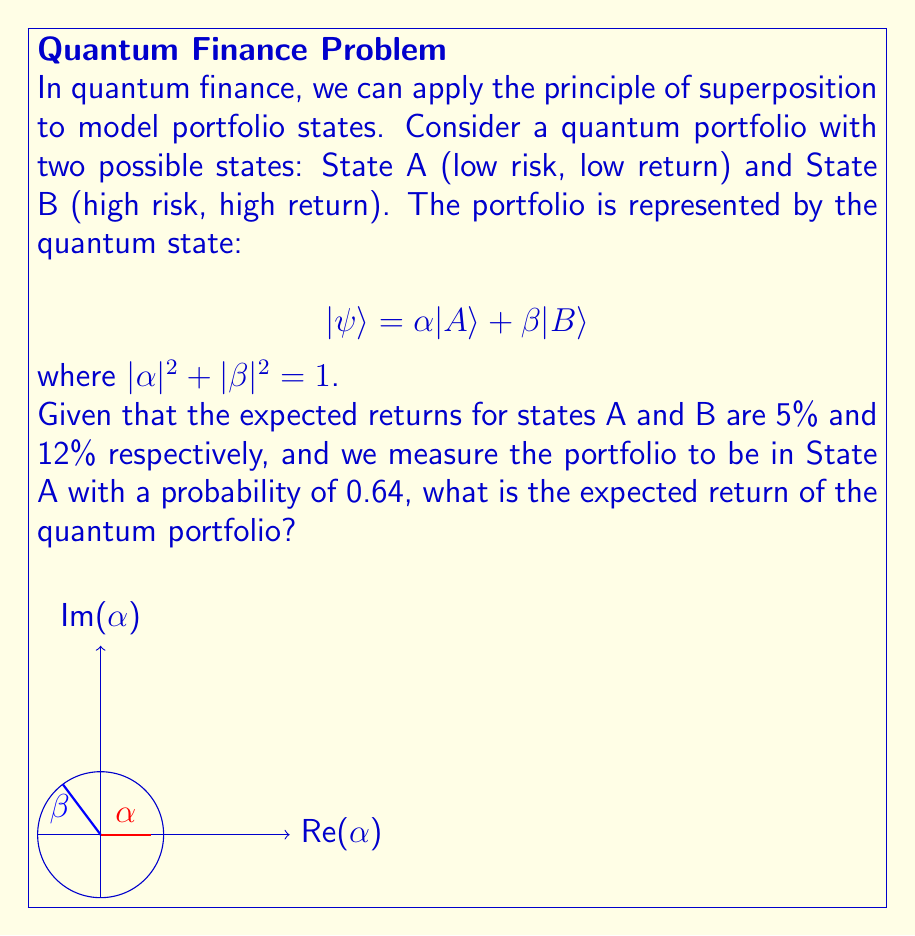Show me your answer to this math problem. Let's approach this step-by-step:

1) First, we need to determine the values of $\alpha$ and $\beta$. We're given that the probability of measuring State A is 0.64. In quantum mechanics, this probability is given by $|\alpha|^2$:

   $$|\alpha|^2 = 0.64$$
   $$\alpha = \sqrt{0.64} = 0.8$$

2) Since $|\alpha|^2 + |\beta|^2 = 1$, we can find $\beta$:

   $$|\beta|^2 = 1 - |\alpha|^2 = 1 - 0.64 = 0.36$$
   $$\beta = \sqrt{0.36} = 0.6$$

3) In quantum finance, the expected return of a superposition state is the weighted sum of the returns of each state, where the weights are the probabilities of measuring each state:

   $$E[R] = |\alpha|^2 R_A + |\beta|^2 R_B$$

   where $R_A$ and $R_B$ are the returns of states A and B respectively.

4) Substituting the values:

   $$E[R] = (0.64)(5\%) + (0.36)(12\%)$$

5) Calculate:

   $$E[R] = 0.032 + 0.0432 = 0.0752$$

6) Convert to percentage:

   $$E[R] = 7.52\%$$

Thus, the expected return of the quantum portfolio is 7.52%.
Answer: 7.52% 